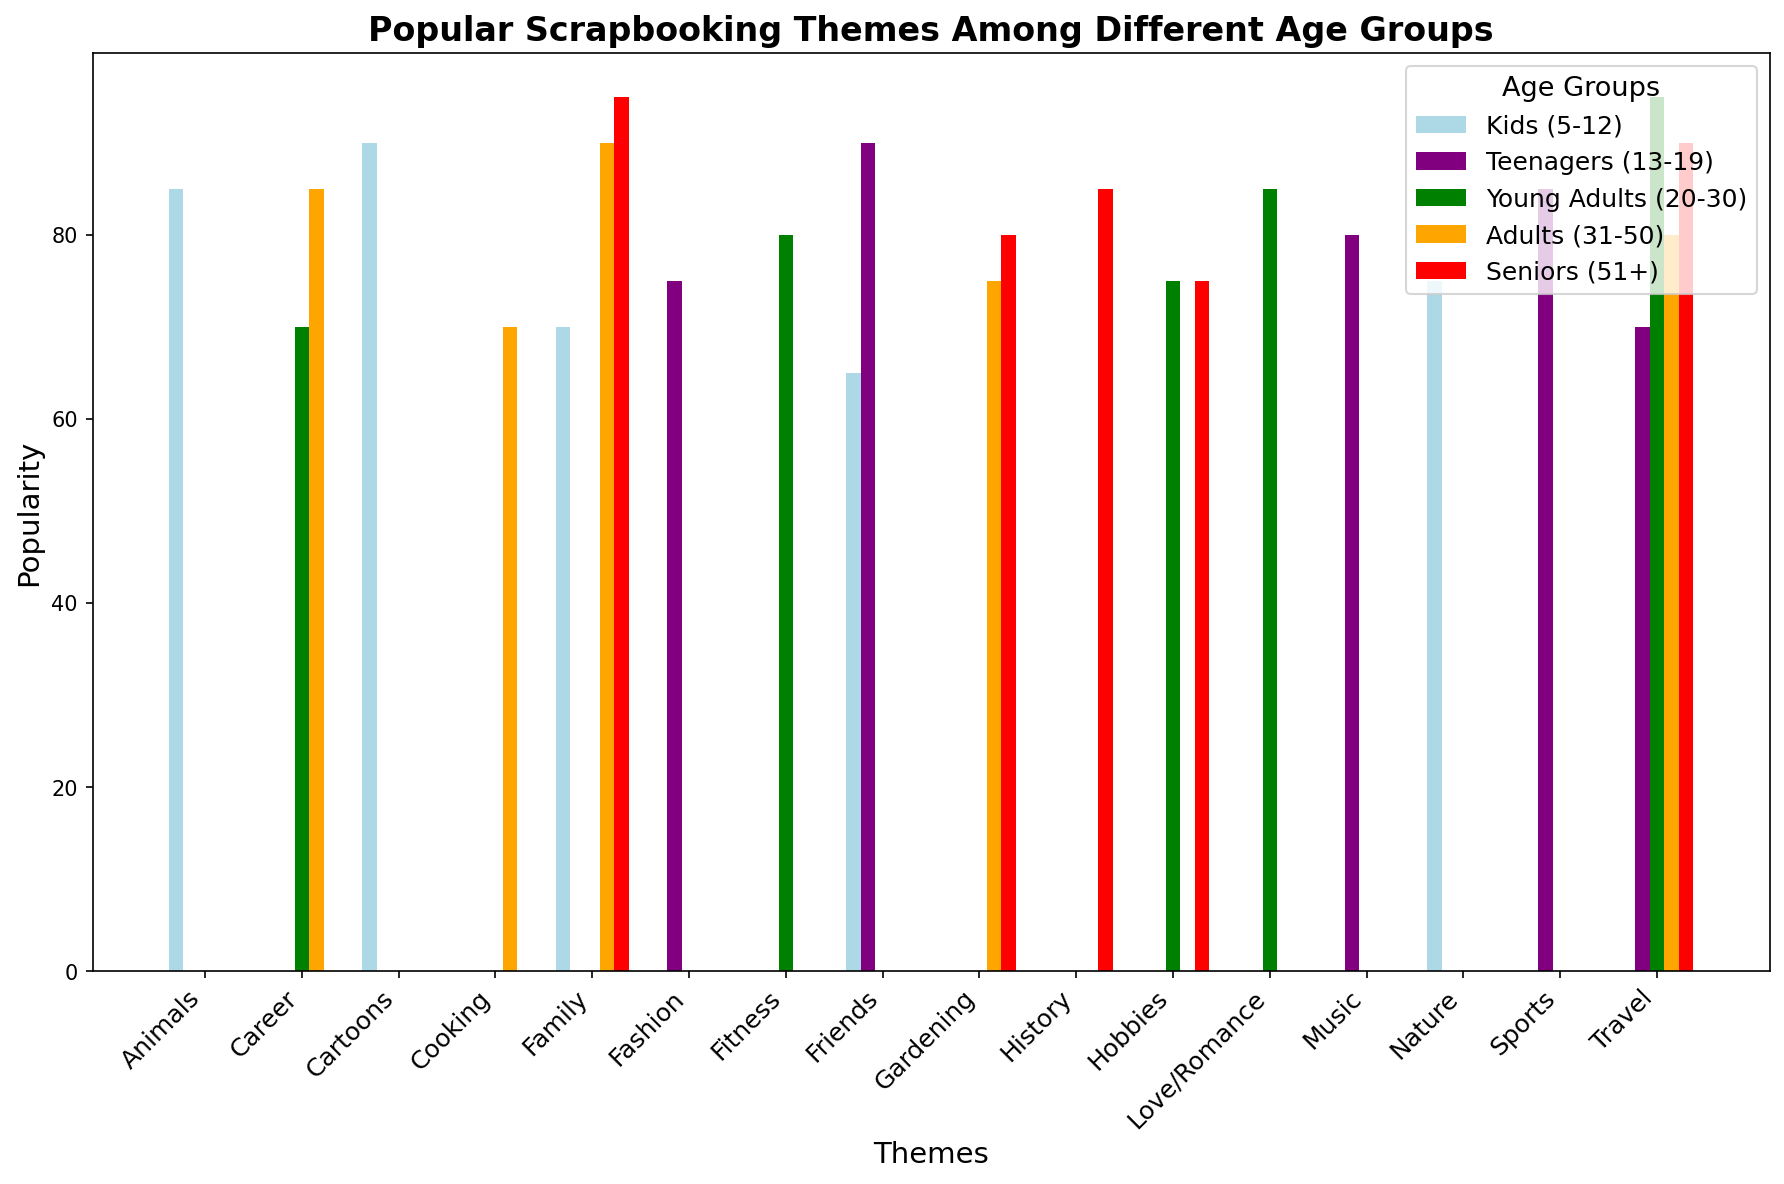Which age group has the highest popularity for the "Travel" theme? The "Travel" theme is represented by different colored bars for each age group. By looking at the heights of these bars, we can see that "Young Adults (20-30)" has the tallest bar.
Answer: Young Adults (20-30) What is the difference in popularity between "Family" for Seniors and "Family" for Adults? Identify the heights of the bars representing "Family" for both Seniors (red) and Adults (orange). The height for Seniors is 95 and for Adults is 90. The difference is calculated as 95 - 90.
Answer: 5 Among Kids, Teenagers, and Young Adults, which age group has the lowest popularity for the "Friends" theme? Compare the heights of the "Friends" theme bars for Kids (light blue), Teenagers (purple), and Young Adults (green). The Teenagers group has the highest bar, followed by Kids, and the lowest is Young Adults.
Answer: Young Adults Which theme is equally popular among Seniors and Adults? Look for bars that have the same height in both red (Seniors) and orange (Adults). The "Gardening" theme has equal bar heights for both groups.
Answer: Gardening What is the average popularity for the "Career" theme across all age groups? Identify the bars for "Career" across each age group: Adults (85), Young Adults (70), and Seniors (not listed). Sum these values: 85 + 70 + 85 = 240, then divide by 3 to get the average.
Answer: 80 Which themes have a popularity of 85 among any age group? Check the heights of bars and find those with the value of 85. Both "Animals" for Kids and "Sports" for Teenagers, as well as "Love/Romance" for Young Adults, match this popularity.
Answer: Animals, Sports, Love/Romance What is the summed popularity of the “Music” and “Sports” themes for Teenagers? Identify the heights of the bars for "Music" and "Sports" for Teenagers, which are 80 and 85 respectively. Sum these values: 80 + 85.
Answer: 165 Which theme has the lowest popularity among Kids (5-12)? Look for the shortest bar in the Kids (light blue) section. The "Friends" theme has the lowest bar height of 65.
Answer: Friends What is the combined popularity of the "Family" theme across all age groups? Sum the values of the "Family" theme for all respective age groups: Kids (70), Adults (90), and Seniors (95). The sum is 70 + 90 + 95.
Answer: 255 How many themes are more popular among "Seniors" than "Young Adults"? Compare the heights of the bars for each theme between Seniors (red) and Young Adults (green). The themes where Seniors have higher popularity are "Family," "Travel," and "History".
Answer: 3 